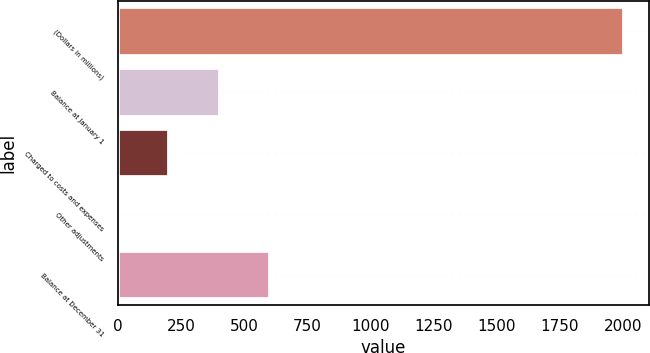Convert chart to OTSL. <chart><loc_0><loc_0><loc_500><loc_500><bar_chart><fcel>(Dollars in millions)<fcel>Balance at January 1<fcel>Charged to costs and expenses<fcel>Other adjustments<fcel>Balance at December 31<nl><fcel>2003<fcel>403<fcel>203<fcel>3<fcel>603<nl></chart> 